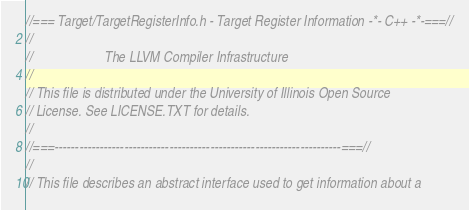Convert code to text. <code><loc_0><loc_0><loc_500><loc_500><_C_>//=== Target/TargetRegisterInfo.h - Target Register Information -*- C++ -*-===//
//
//                     The LLVM Compiler Infrastructure
//
// This file is distributed under the University of Illinois Open Source
// License. See LICENSE.TXT for details.
//
//===----------------------------------------------------------------------===//
//
// This file describes an abstract interface used to get information about a</code> 